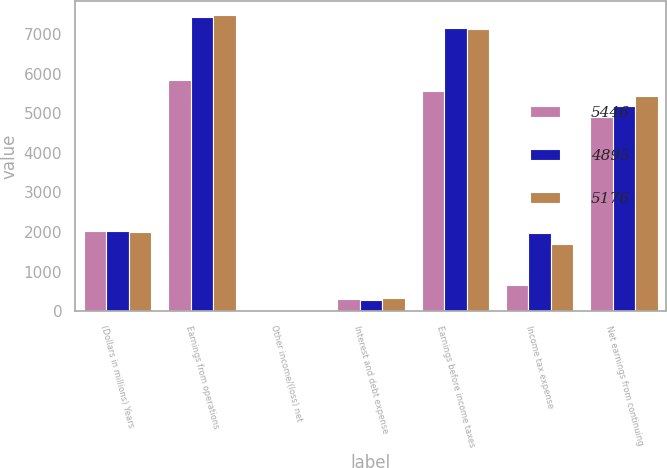Convert chart. <chart><loc_0><loc_0><loc_500><loc_500><stacked_bar_chart><ecel><fcel>(Dollars in millions) Years<fcel>Earnings from operations<fcel>Other income/(loss) net<fcel>Interest and debt expense<fcel>Earnings before income taxes<fcel>Income tax expense<fcel>Net earnings from continuing<nl><fcel>5446<fcel>2016<fcel>5834<fcel>40<fcel>306<fcel>5568<fcel>673<fcel>4895<nl><fcel>4895<fcel>2015<fcel>7443<fcel>13<fcel>275<fcel>7155<fcel>1979<fcel>5176<nl><fcel>5176<fcel>2014<fcel>7473<fcel>3<fcel>333<fcel>7137<fcel>1691<fcel>5446<nl></chart> 